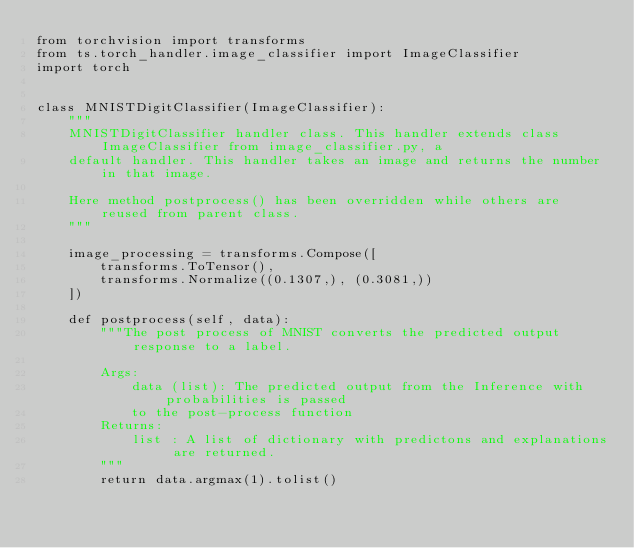Convert code to text. <code><loc_0><loc_0><loc_500><loc_500><_Python_>from torchvision import transforms
from ts.torch_handler.image_classifier import ImageClassifier
import torch


class MNISTDigitClassifier(ImageClassifier):
    """
    MNISTDigitClassifier handler class. This handler extends class ImageClassifier from image_classifier.py, a
    default handler. This handler takes an image and returns the number in that image.

    Here method postprocess() has been overridden while others are reused from parent class.
    """

    image_processing = transforms.Compose([
        transforms.ToTensor(),
        transforms.Normalize((0.1307,), (0.3081,))
    ])

    def postprocess(self, data):
        """The post process of MNIST converts the predicted output response to a label.

        Args:
            data (list): The predicted output from the Inference with probabilities is passed
            to the post-process function
        Returns:
            list : A list of dictionary with predictons and explanations are returned.
        """
        return data.argmax(1).tolist()
        </code> 